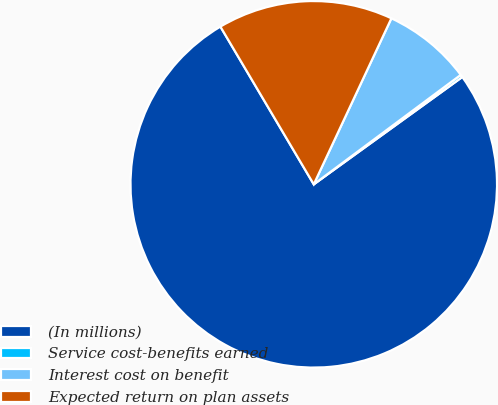Convert chart to OTSL. <chart><loc_0><loc_0><loc_500><loc_500><pie_chart><fcel>(In millions)<fcel>Service cost-benefits earned<fcel>Interest cost on benefit<fcel>Expected return on plan assets<nl><fcel>76.45%<fcel>0.23%<fcel>7.85%<fcel>15.47%<nl></chart> 